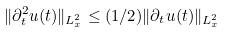<formula> <loc_0><loc_0><loc_500><loc_500>\| \partial _ { t } ^ { 2 } u ( t ) \| _ { L ^ { 2 } _ { x } } \leq ( 1 / 2 ) \| \partial _ { t } u ( t ) \| _ { L ^ { 2 } _ { x } }</formula> 